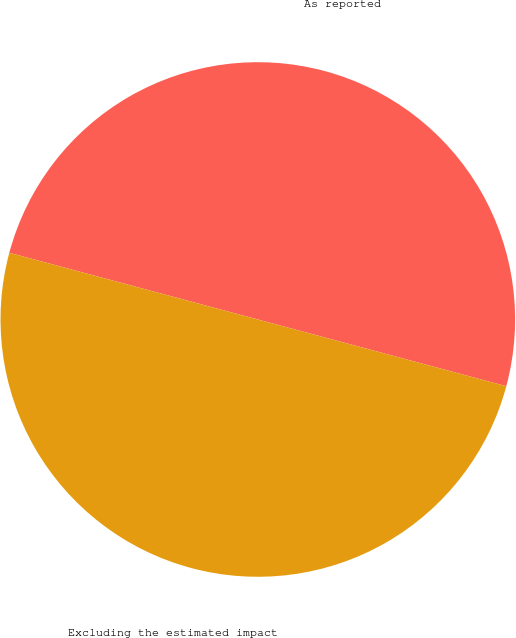<chart> <loc_0><loc_0><loc_500><loc_500><pie_chart><fcel>As reported<fcel>Excluding the estimated impact<nl><fcel>50.0%<fcel>50.0%<nl></chart> 